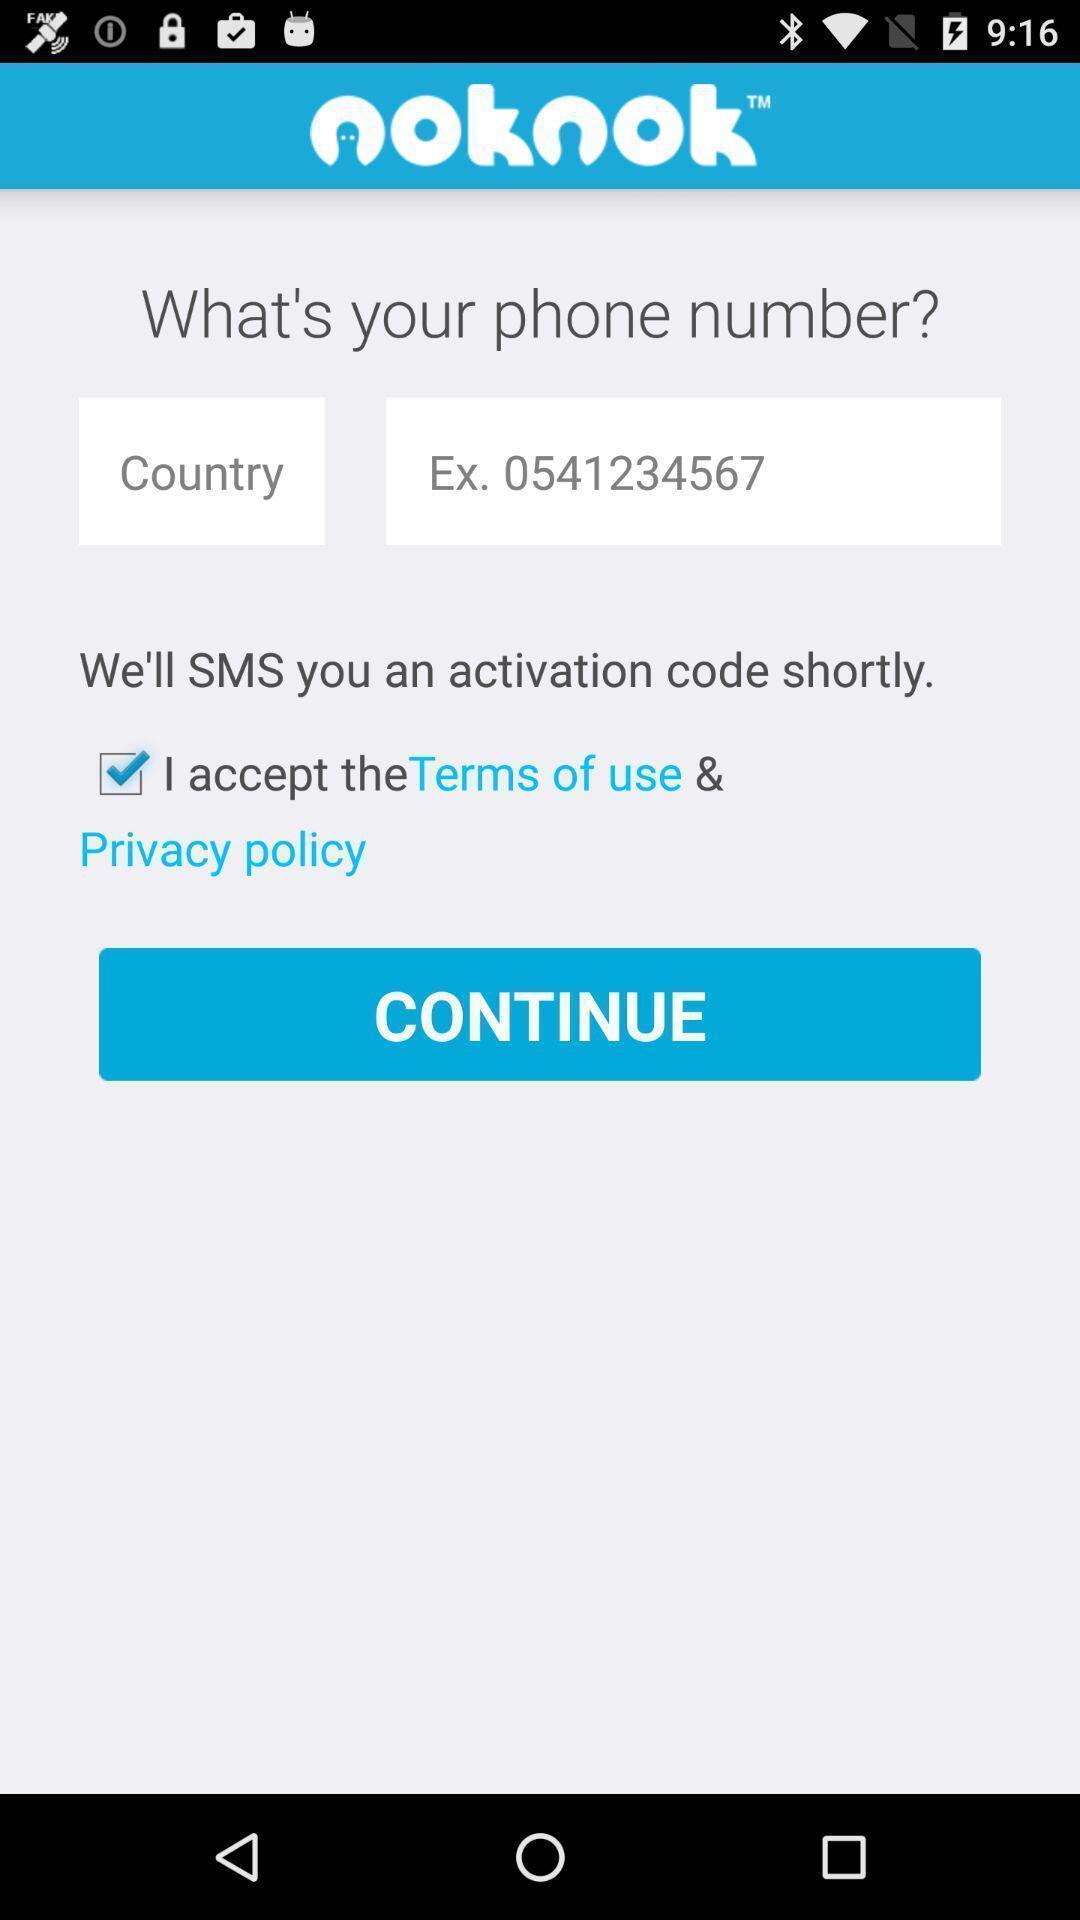Give me a narrative description of this picture. Screen shows multiple options. 